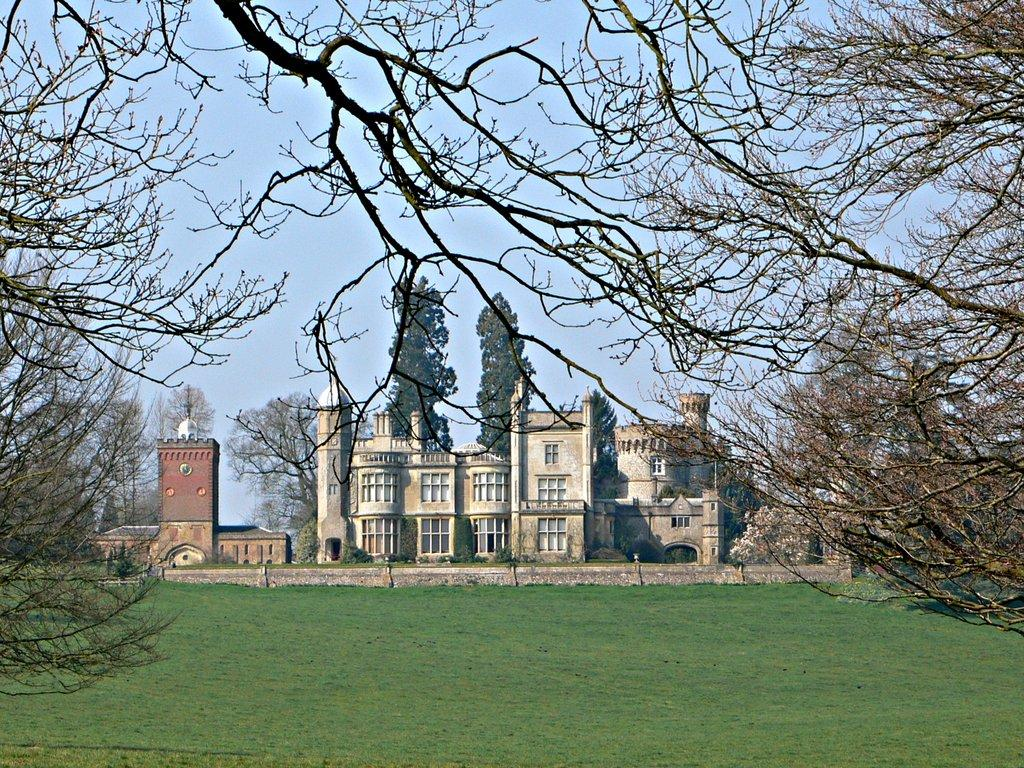What type of vegetation can be seen in the image? There are trees and grass in the image. What can be seen in the background of the image? There are walls, buildings, plants, trees, and the sky visible in the background of the image. Can you tell me how many giraffes are visible in the image? There are no giraffes present in the image. What type of engine can be seen powering the trees in the image? There is no engine present in the image, and trees do not require engines to function. 